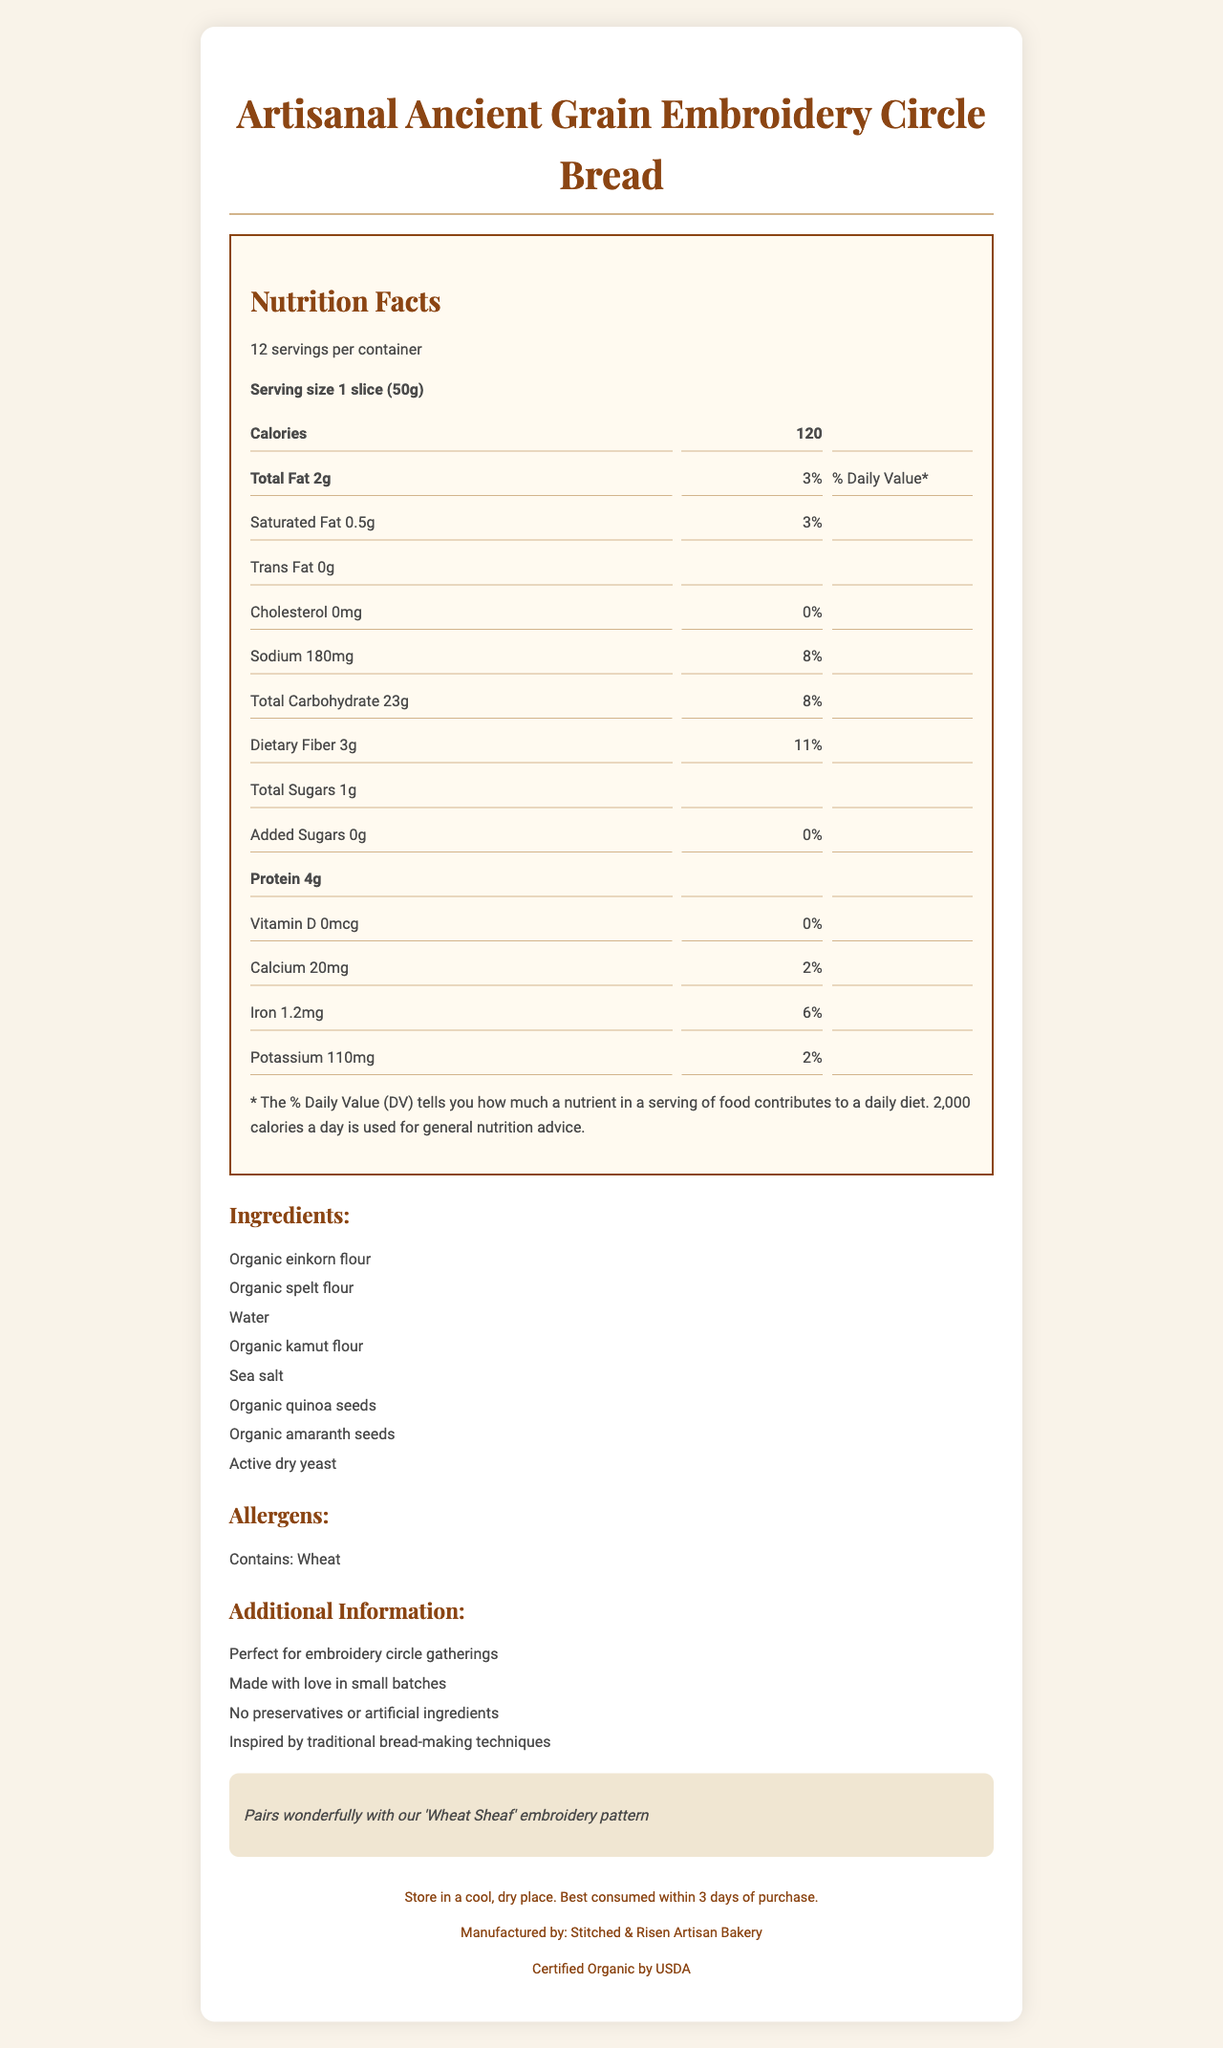Can you tell me the serving size of the Artisanal Ancient Grain Embroidery Circle Bread? The serving size information is provided as "1 slice (50g)" in the document.
Answer: 1 slice (50g) How many servings are there per container? The document states that there are 12 servings per container.
Answer: 12 What is the total fat content per serving? The total fat content per serving is listed as "2g."
Answer: 2g How much sodium is in each serving of the bread? The sodium content per serving is mentioned as "180mg" in the document.
Answer: 180mg Does the bread contain any trans fat? The document indicates that the trans fat content is "0g."
Answer: No How much dietary fiber is in each serving? The dietary fiber content per serving is listed as "3g."
Answer: 3g What is the protein content per serving? The protein content per serving is mentioned as "4g" in the document.
Answer: 4g Does this bread contain any added sugars? The document states that the amount of added sugars is "0g."
Answer: No How much iron is in each serving, and what percentage of the daily value does that represent? The iron content is 1.2mg, which represents 6% of the daily value.
Answer: 1.2mg, 6% Which ingredient is listed first? The ingredients list begins with "Organic einkorn flour."
Answer: Organic einkorn flour What is the calcium content per serving? A. 20mg B. 50mg C. 100mg The document lists the calcium content as "20mg" per serving.
Answer: A How is this bread recommended to be stored? A. In the refrigerator B. In a cool, dry place C. In the freezer The storage instructions specify storing the bread in a cool, dry place.
Answer: B Is this bread certified organic? The document states that the bread is "Certified Organic by USDA."
Answer: Yes Who is the manufacturer of this bread? The manufacturer's name is "Stitched & Risen Artisan Bakery."
Answer: Stitched & Risen Artisan Bakery What is the main idea of the document? The document covers multiple aspects such as nutrition facts, ingredients, allergens, and additional information that highlights the bread's suitability for embroidery gatherings, organic certification, and traditional bread-making techniques.
Answer: The document provides nutritional information, ingredients, storage instructions, and other details for Artisanal Ancient Grain Embroidery Circle Bread, a traditional bread perfect for embroidery circle gatherings. Why was the bread called "perfect for embroidery circle gatherings"? The document states that the bread is perfect for embroidery circle gatherings but does not provide a specific reason why.
Answer: Not enough information Does this bread contain any preservatives or artificial ingredients? The additional information section specifies that the bread contains no preservatives or artificial ingredients.
Answer: No 